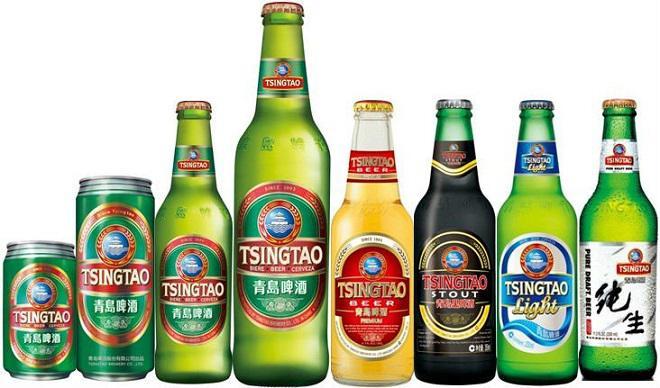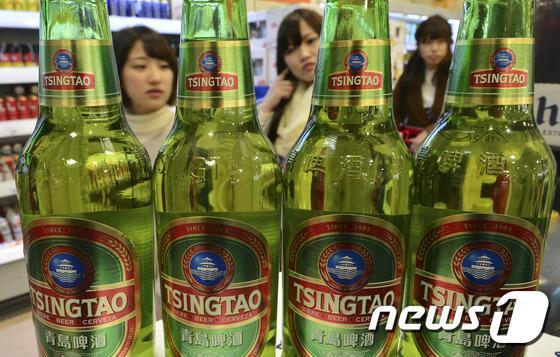The first image is the image on the left, the second image is the image on the right. Given the left and right images, does the statement "There are exactly five bottles of beer in the left image." hold true? Answer yes or no. No. The first image is the image on the left, the second image is the image on the right. For the images shown, is this caption "In at least one image there are five unopened green beer bottles." true? Answer yes or no. Yes. 